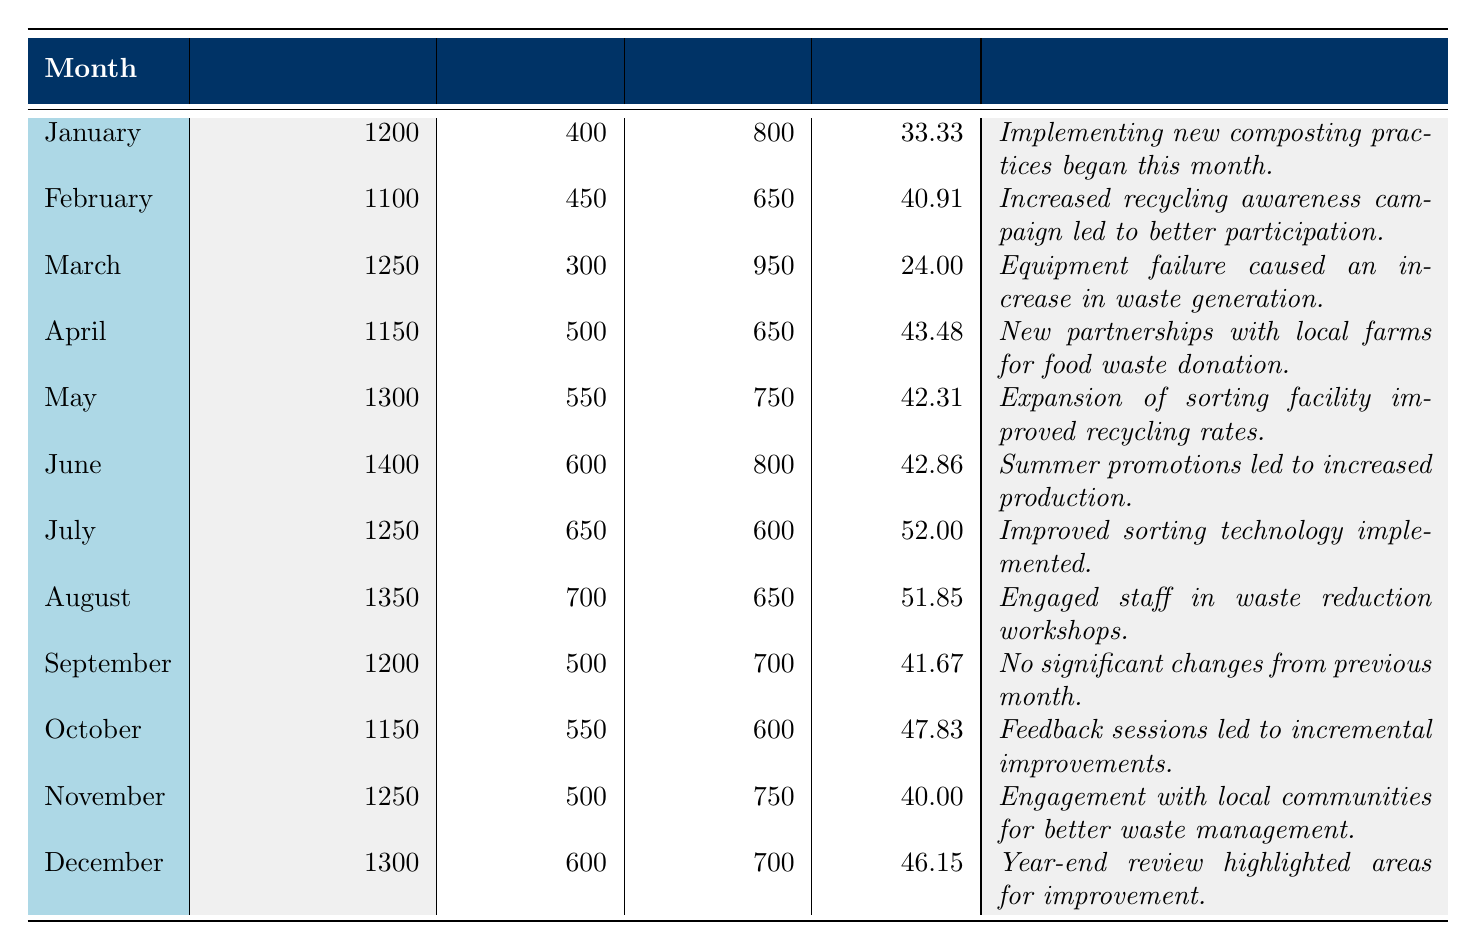What was the total waste generated in June? The table lists June with a total waste generated of 1400 kg.
Answer: 1400 kg What was the recycling rate in April? The recycling rate for April is specified in the table as 43.48%.
Answer: 43.48% Which month had the highest recycling rate? By reviewing the recycling rates for each month, July had the highest rate at 52.00%.
Answer: 52.00% Was there any month where the recycling rate dropped below 25%? Checking the recycling rates, March had a rate of 24.00%, which is below 25%.
Answer: Yes What is the average recycling rate over the year? To find the average, sum the recycling rates (33.33 + 40.91 + 24.00 + 43.48 + 42.31 + 42.86 + 52.00 + 51.85 + 41.67 + 47.83 + 40.00 + 46.15) to get 468.58% and divide by 12 months, which equals 39.05%.
Answer: 39.05% How much food waste was generated in February compared to March? In February, food waste was 650 kg, while in March it was 950 kg; the difference is 950 - 650 = 300 kg more in March.
Answer: 300 kg more in March Which month experienced an increase in total waste despite improvements in recycling? June had the highest total waste at 1400 kg, yet the recycling rate remained relatively high at 42.86%, indicating increased production led to more waste.
Answer: June What were the notes for the month with the lowest recycling rate? March had the lowest recycling rate of 24.00% due to equipment failure, as noted in the table.
Answer: Equipment failure caused an increase in waste generation Did the total waste generation increase or decrease from January to December? January's total waste was 1200 kg and December's was 1300 kg; therefore, total waste generation increased.
Answer: Increased What was the total amount of recyclable waste generated over the year? Summing the recyclable waste amounts from each month (400 + 450 + 300 + 500 + 550 + 600 + 650 + 700 + 500 + 550 + 500 + 600) gives a total of 6050 kg.
Answer: 6050 kg 